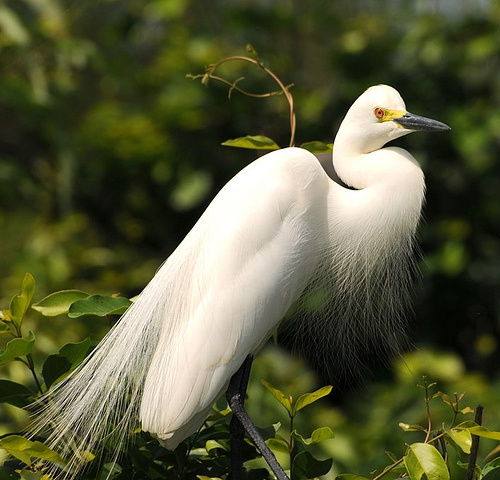Describe the objects in this image and their specific colors. I can see a bird in darkgreen, ivory, darkgray, lightgray, and gray tones in this image. 